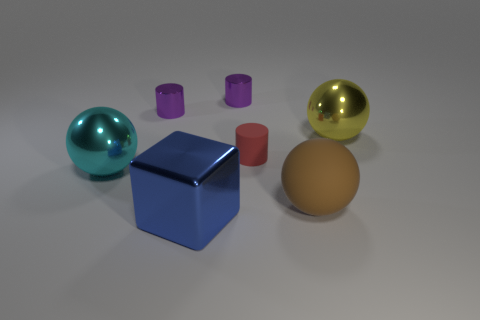Add 3 tiny cyan rubber cylinders. How many objects exist? 10 Subtract all blocks. How many objects are left? 6 Add 3 yellow shiny balls. How many yellow shiny balls exist? 4 Subtract 0 cyan cubes. How many objects are left? 7 Subtract all large blue shiny things. Subtract all large yellow metallic things. How many objects are left? 5 Add 7 cyan objects. How many cyan objects are left? 8 